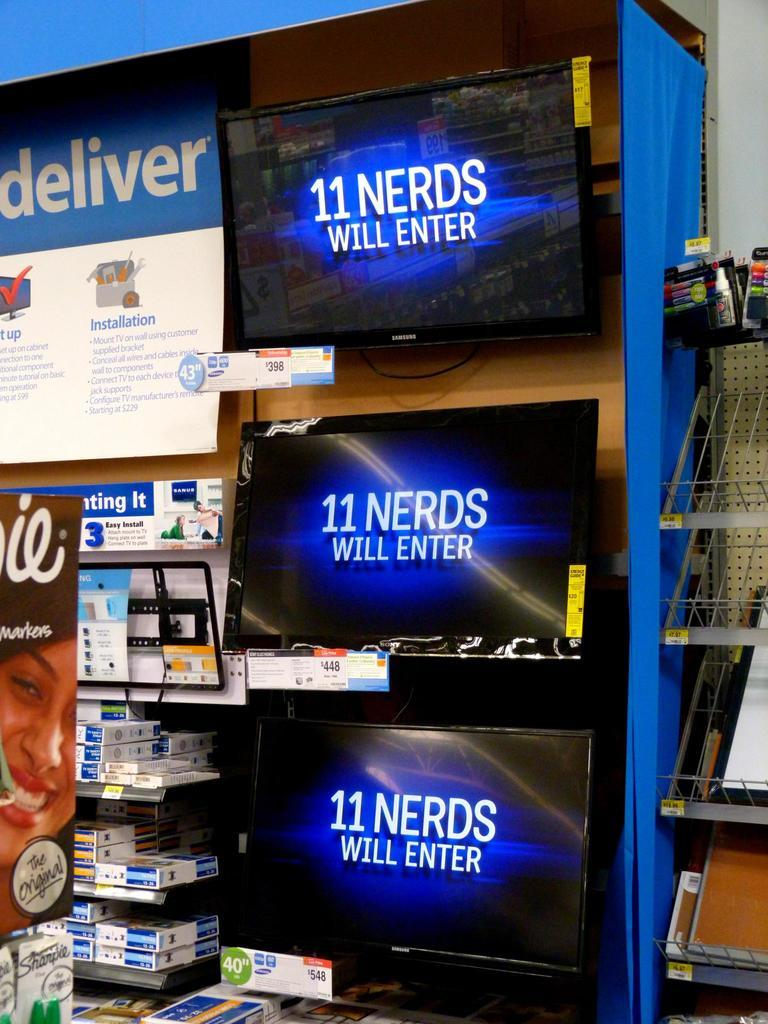<image>
Render a clear and concise summary of the photo. Three TV screens display the phrase, 11 nerds will enter in a shop. 